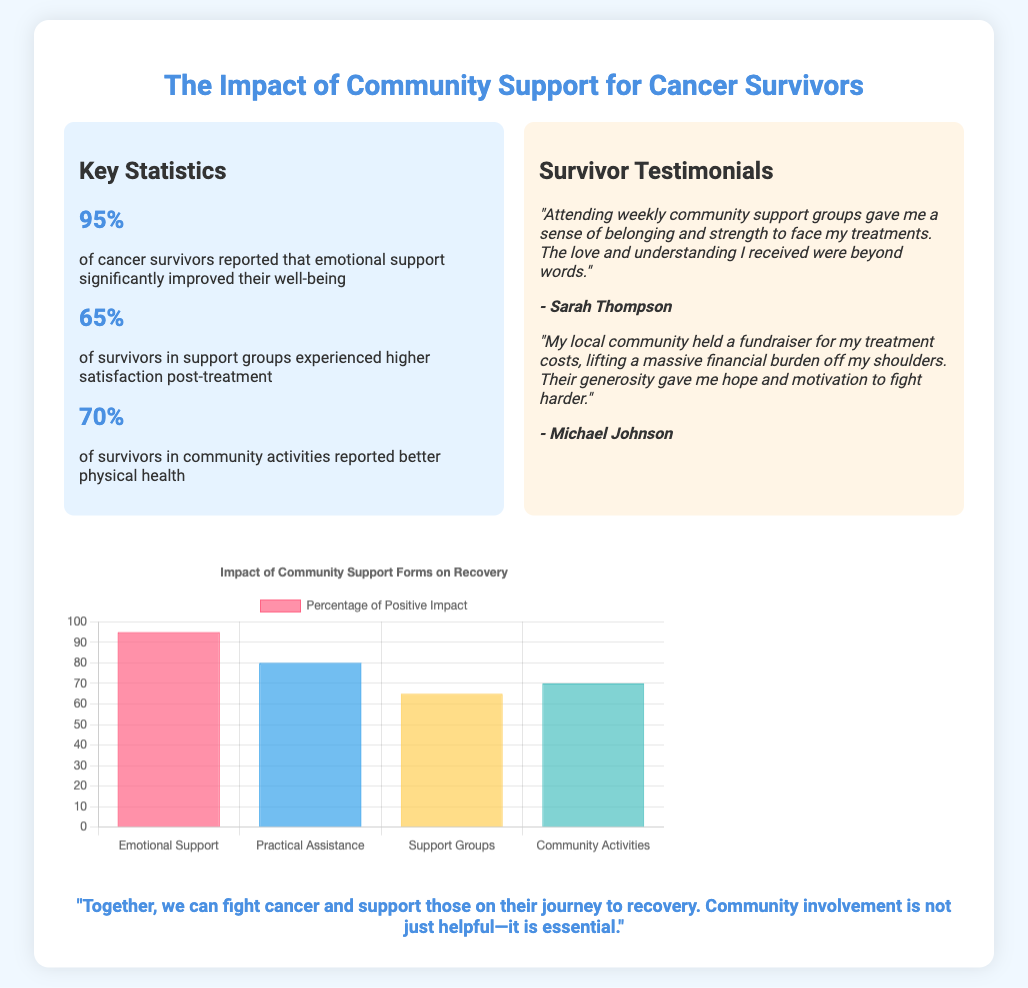What percentage of cancer survivors reported improved well-being from emotional support? The document states that 95% of cancer survivors reported that emotional support significantly improved their well-being.
Answer: 95% How many survivors in support groups experienced higher satisfaction post-treatment? According to the slide, 65% of survivors in support groups experienced higher satisfaction post-treatment.
Answer: 65% What is the key statistic regarding better physical health from community activities? The document mentions that 70% of survivors in community activities reported better physical health.
Answer: 70% Who mentioned that community support groups gave them a sense of belonging? Sarah Thompson provided this testimonial about community support groups.
Answer: Sarah Thompson What type of community support lifted a financial burden off a survivor? Michael Johnson's testimonial indicates that fundraising by the local community lifted his financial burden.
Answer: Fundraising What does the chart in the document illustrate? The chart illustrates the impact of various forms of community support on recovery with percentages.
Answer: Impact of Community Support Forms on Recovery In which section is the quote about fighting cancer located? The quote about fighting cancer is located in the quote section of the slide.
Answer: Quote section What is the highest percentage connected to community support listed in the document? The highest percentage related to community support is 95%, corresponding to emotional support.
Answer: 95% How is the content structured in the slide presentation? The content is structured with key statistics, testimonials, a chart, and a quote.
Answer: Key statistics, testimonials, chart, quote 